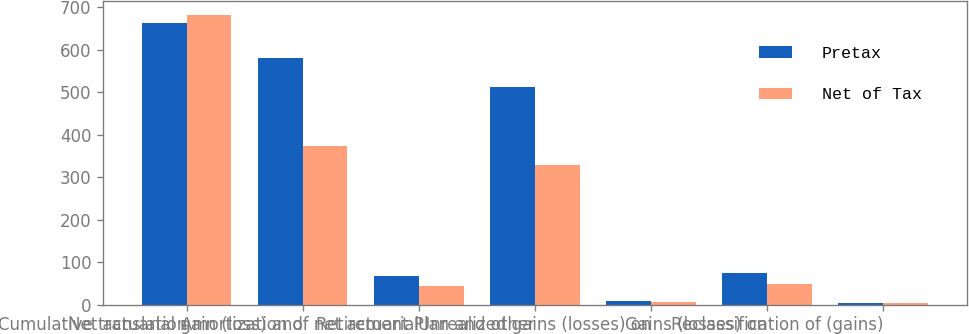Convert chart to OTSL. <chart><loc_0><loc_0><loc_500><loc_500><stacked_bar_chart><ecel><fcel>Cumulative translation<fcel>Net actuarial gain (loss) and<fcel>Amortization of net actuarial<fcel>Retirement Plan and other<fcel>Unrealized gains (losses) on<fcel>Gains (losses) on<fcel>Reclassification of (gains)<nl><fcel>Pretax<fcel>663<fcel>580<fcel>67<fcel>513<fcel>9<fcel>74<fcel>5<nl><fcel>Net of Tax<fcel>681<fcel>374<fcel>45<fcel>329<fcel>6<fcel>48<fcel>4<nl></chart> 